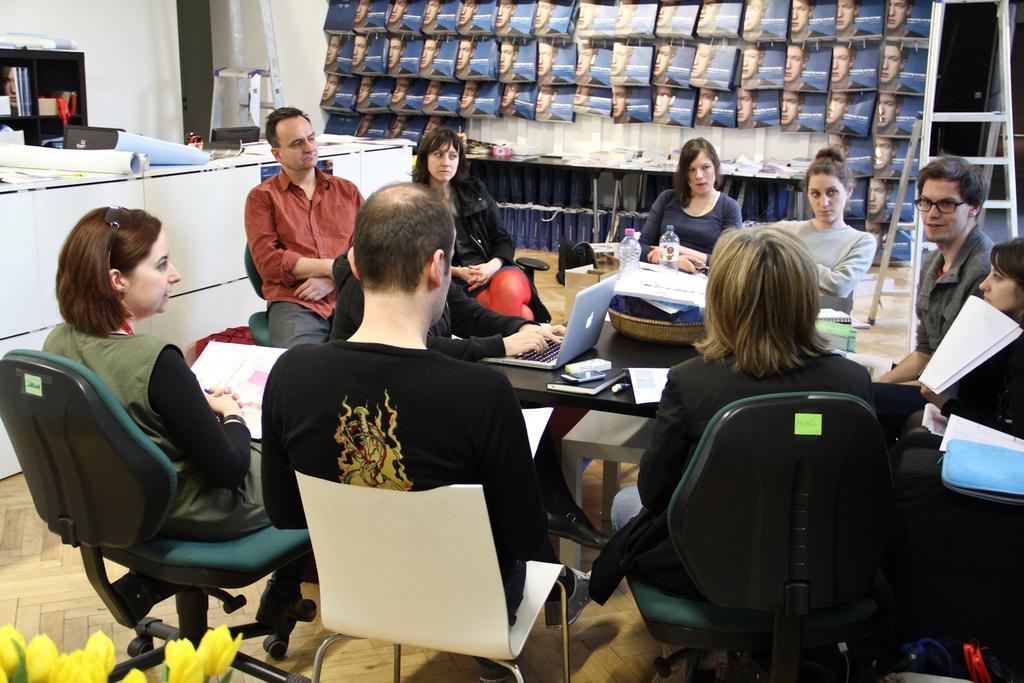Can you describe this image briefly? This picture might be taken inside the room. In this image, we can see a group of people sitting on the chair in front of the table, on that table, we can see a laptop, water bottle, basket, books. On the left side, we can see another table, on that table, we can see some charts, papers. In the middle of the image, we can also see some books, some books and a ladder. On the left side, we can see a shelf, on the shelf, we can see some books. On the left corner, we can see flowers which are in yellow color. 